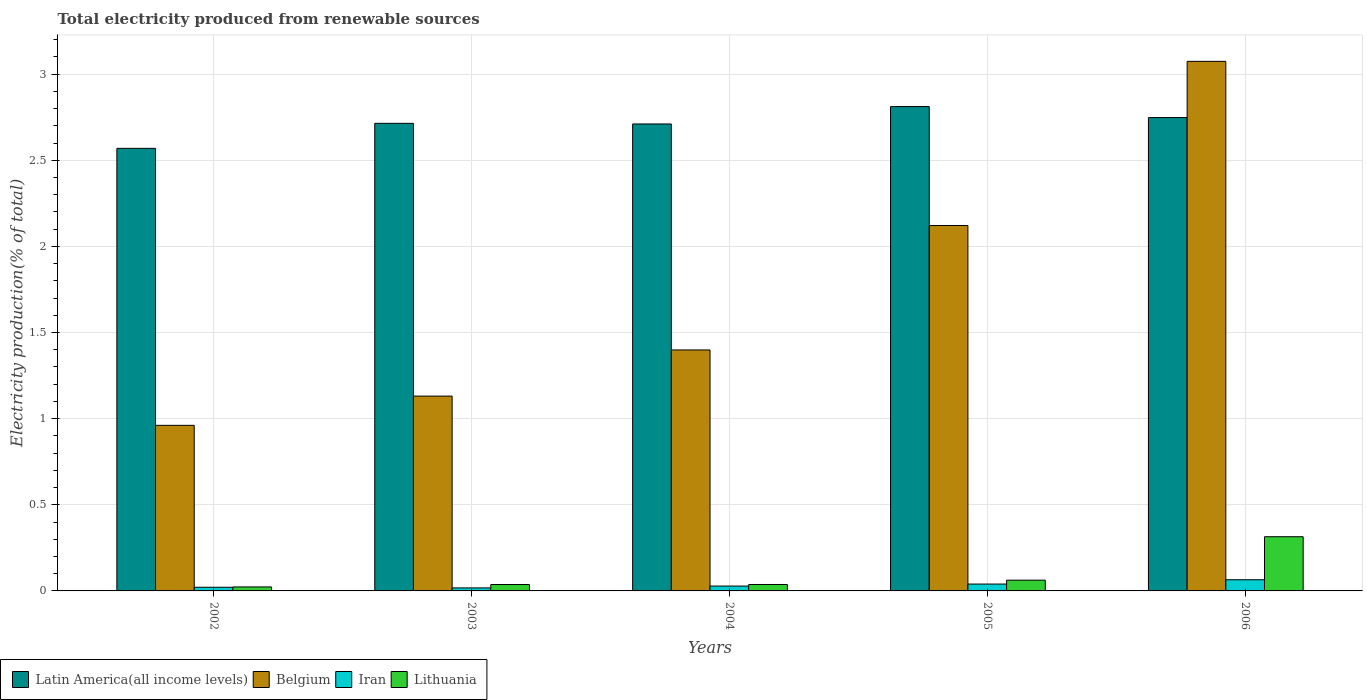How many different coloured bars are there?
Your answer should be compact. 4. How many groups of bars are there?
Give a very brief answer. 5. Are the number of bars per tick equal to the number of legend labels?
Keep it short and to the point. Yes. Are the number of bars on each tick of the X-axis equal?
Your answer should be very brief. Yes. How many bars are there on the 1st tick from the right?
Your answer should be very brief. 4. What is the label of the 2nd group of bars from the left?
Keep it short and to the point. 2003. In how many cases, is the number of bars for a given year not equal to the number of legend labels?
Provide a short and direct response. 0. What is the total electricity produced in Belgium in 2006?
Give a very brief answer. 3.07. Across all years, what is the maximum total electricity produced in Lithuania?
Your answer should be compact. 0.31. Across all years, what is the minimum total electricity produced in Belgium?
Keep it short and to the point. 0.96. In which year was the total electricity produced in Belgium maximum?
Give a very brief answer. 2006. What is the total total electricity produced in Latin America(all income levels) in the graph?
Provide a short and direct response. 13.55. What is the difference between the total electricity produced in Iran in 2002 and that in 2005?
Give a very brief answer. -0.02. What is the difference between the total electricity produced in Belgium in 2005 and the total electricity produced in Latin America(all income levels) in 2006?
Your answer should be very brief. -0.63. What is the average total electricity produced in Belgium per year?
Keep it short and to the point. 1.74. In the year 2005, what is the difference between the total electricity produced in Iran and total electricity produced in Latin America(all income levels)?
Keep it short and to the point. -2.77. What is the ratio of the total electricity produced in Iran in 2002 to that in 2006?
Your answer should be very brief. 0.33. Is the total electricity produced in Belgium in 2005 less than that in 2006?
Offer a terse response. Yes. What is the difference between the highest and the second highest total electricity produced in Latin America(all income levels)?
Give a very brief answer. 0.06. What is the difference between the highest and the lowest total electricity produced in Belgium?
Offer a terse response. 2.11. Is it the case that in every year, the sum of the total electricity produced in Latin America(all income levels) and total electricity produced in Lithuania is greater than the sum of total electricity produced in Iran and total electricity produced in Belgium?
Your answer should be very brief. No. What does the 3rd bar from the left in 2003 represents?
Your answer should be compact. Iran. What does the 1st bar from the right in 2002 represents?
Make the answer very short. Lithuania. How many bars are there?
Offer a terse response. 20. How many years are there in the graph?
Offer a terse response. 5. Are the values on the major ticks of Y-axis written in scientific E-notation?
Provide a succinct answer. No. Does the graph contain any zero values?
Your answer should be very brief. No. Does the graph contain grids?
Give a very brief answer. Yes. What is the title of the graph?
Offer a terse response. Total electricity produced from renewable sources. What is the Electricity production(% of total) of Latin America(all income levels) in 2002?
Keep it short and to the point. 2.57. What is the Electricity production(% of total) in Belgium in 2002?
Give a very brief answer. 0.96. What is the Electricity production(% of total) in Iran in 2002?
Your answer should be very brief. 0.02. What is the Electricity production(% of total) of Lithuania in 2002?
Your answer should be very brief. 0.02. What is the Electricity production(% of total) in Latin America(all income levels) in 2003?
Your answer should be compact. 2.71. What is the Electricity production(% of total) of Belgium in 2003?
Ensure brevity in your answer.  1.13. What is the Electricity production(% of total) in Iran in 2003?
Provide a succinct answer. 0.02. What is the Electricity production(% of total) in Lithuania in 2003?
Keep it short and to the point. 0.04. What is the Electricity production(% of total) in Latin America(all income levels) in 2004?
Keep it short and to the point. 2.71. What is the Electricity production(% of total) in Belgium in 2004?
Ensure brevity in your answer.  1.4. What is the Electricity production(% of total) of Iran in 2004?
Offer a terse response. 0.03. What is the Electricity production(% of total) of Lithuania in 2004?
Your answer should be compact. 0.04. What is the Electricity production(% of total) of Latin America(all income levels) in 2005?
Keep it short and to the point. 2.81. What is the Electricity production(% of total) of Belgium in 2005?
Your response must be concise. 2.12. What is the Electricity production(% of total) in Iran in 2005?
Offer a terse response. 0.04. What is the Electricity production(% of total) in Lithuania in 2005?
Keep it short and to the point. 0.06. What is the Electricity production(% of total) of Latin America(all income levels) in 2006?
Offer a terse response. 2.75. What is the Electricity production(% of total) in Belgium in 2006?
Keep it short and to the point. 3.07. What is the Electricity production(% of total) of Iran in 2006?
Keep it short and to the point. 0.06. What is the Electricity production(% of total) in Lithuania in 2006?
Offer a terse response. 0.31. Across all years, what is the maximum Electricity production(% of total) in Latin America(all income levels)?
Make the answer very short. 2.81. Across all years, what is the maximum Electricity production(% of total) in Belgium?
Make the answer very short. 3.07. Across all years, what is the maximum Electricity production(% of total) in Iran?
Your answer should be very brief. 0.06. Across all years, what is the maximum Electricity production(% of total) in Lithuania?
Provide a short and direct response. 0.31. Across all years, what is the minimum Electricity production(% of total) of Latin America(all income levels)?
Provide a short and direct response. 2.57. Across all years, what is the minimum Electricity production(% of total) in Belgium?
Offer a very short reply. 0.96. Across all years, what is the minimum Electricity production(% of total) in Iran?
Your answer should be compact. 0.02. Across all years, what is the minimum Electricity production(% of total) in Lithuania?
Make the answer very short. 0.02. What is the total Electricity production(% of total) of Latin America(all income levels) in the graph?
Ensure brevity in your answer.  13.55. What is the total Electricity production(% of total) in Belgium in the graph?
Offer a very short reply. 8.69. What is the total Electricity production(% of total) of Iran in the graph?
Your answer should be compact. 0.17. What is the total Electricity production(% of total) in Lithuania in the graph?
Keep it short and to the point. 0.47. What is the difference between the Electricity production(% of total) of Latin America(all income levels) in 2002 and that in 2003?
Provide a short and direct response. -0.15. What is the difference between the Electricity production(% of total) of Belgium in 2002 and that in 2003?
Keep it short and to the point. -0.17. What is the difference between the Electricity production(% of total) of Iran in 2002 and that in 2003?
Make the answer very short. 0. What is the difference between the Electricity production(% of total) of Lithuania in 2002 and that in 2003?
Keep it short and to the point. -0.01. What is the difference between the Electricity production(% of total) in Latin America(all income levels) in 2002 and that in 2004?
Ensure brevity in your answer.  -0.14. What is the difference between the Electricity production(% of total) of Belgium in 2002 and that in 2004?
Ensure brevity in your answer.  -0.44. What is the difference between the Electricity production(% of total) of Iran in 2002 and that in 2004?
Offer a terse response. -0.01. What is the difference between the Electricity production(% of total) in Lithuania in 2002 and that in 2004?
Your answer should be very brief. -0.01. What is the difference between the Electricity production(% of total) of Latin America(all income levels) in 2002 and that in 2005?
Your answer should be very brief. -0.24. What is the difference between the Electricity production(% of total) in Belgium in 2002 and that in 2005?
Your answer should be very brief. -1.16. What is the difference between the Electricity production(% of total) in Iran in 2002 and that in 2005?
Offer a very short reply. -0.02. What is the difference between the Electricity production(% of total) of Lithuania in 2002 and that in 2005?
Ensure brevity in your answer.  -0.04. What is the difference between the Electricity production(% of total) of Latin America(all income levels) in 2002 and that in 2006?
Ensure brevity in your answer.  -0.18. What is the difference between the Electricity production(% of total) in Belgium in 2002 and that in 2006?
Make the answer very short. -2.11. What is the difference between the Electricity production(% of total) in Iran in 2002 and that in 2006?
Give a very brief answer. -0.04. What is the difference between the Electricity production(% of total) in Lithuania in 2002 and that in 2006?
Provide a succinct answer. -0.29. What is the difference between the Electricity production(% of total) of Latin America(all income levels) in 2003 and that in 2004?
Give a very brief answer. 0. What is the difference between the Electricity production(% of total) of Belgium in 2003 and that in 2004?
Provide a succinct answer. -0.27. What is the difference between the Electricity production(% of total) of Iran in 2003 and that in 2004?
Offer a terse response. -0.01. What is the difference between the Electricity production(% of total) of Lithuania in 2003 and that in 2004?
Make the answer very short. -0. What is the difference between the Electricity production(% of total) of Latin America(all income levels) in 2003 and that in 2005?
Give a very brief answer. -0.1. What is the difference between the Electricity production(% of total) in Belgium in 2003 and that in 2005?
Your answer should be very brief. -0.99. What is the difference between the Electricity production(% of total) of Iran in 2003 and that in 2005?
Your response must be concise. -0.02. What is the difference between the Electricity production(% of total) of Lithuania in 2003 and that in 2005?
Your response must be concise. -0.03. What is the difference between the Electricity production(% of total) in Latin America(all income levels) in 2003 and that in 2006?
Ensure brevity in your answer.  -0.03. What is the difference between the Electricity production(% of total) in Belgium in 2003 and that in 2006?
Your answer should be compact. -1.94. What is the difference between the Electricity production(% of total) of Iran in 2003 and that in 2006?
Your answer should be compact. -0.05. What is the difference between the Electricity production(% of total) of Lithuania in 2003 and that in 2006?
Give a very brief answer. -0.28. What is the difference between the Electricity production(% of total) in Latin America(all income levels) in 2004 and that in 2005?
Your answer should be compact. -0.1. What is the difference between the Electricity production(% of total) of Belgium in 2004 and that in 2005?
Ensure brevity in your answer.  -0.72. What is the difference between the Electricity production(% of total) of Iran in 2004 and that in 2005?
Offer a terse response. -0.01. What is the difference between the Electricity production(% of total) in Lithuania in 2004 and that in 2005?
Make the answer very short. -0.03. What is the difference between the Electricity production(% of total) of Latin America(all income levels) in 2004 and that in 2006?
Give a very brief answer. -0.04. What is the difference between the Electricity production(% of total) of Belgium in 2004 and that in 2006?
Offer a terse response. -1.68. What is the difference between the Electricity production(% of total) in Iran in 2004 and that in 2006?
Offer a very short reply. -0.04. What is the difference between the Electricity production(% of total) of Lithuania in 2004 and that in 2006?
Your response must be concise. -0.28. What is the difference between the Electricity production(% of total) of Latin America(all income levels) in 2005 and that in 2006?
Your answer should be very brief. 0.06. What is the difference between the Electricity production(% of total) in Belgium in 2005 and that in 2006?
Your answer should be very brief. -0.95. What is the difference between the Electricity production(% of total) of Iran in 2005 and that in 2006?
Ensure brevity in your answer.  -0.03. What is the difference between the Electricity production(% of total) in Lithuania in 2005 and that in 2006?
Make the answer very short. -0.25. What is the difference between the Electricity production(% of total) of Latin America(all income levels) in 2002 and the Electricity production(% of total) of Belgium in 2003?
Your answer should be very brief. 1.44. What is the difference between the Electricity production(% of total) in Latin America(all income levels) in 2002 and the Electricity production(% of total) in Iran in 2003?
Give a very brief answer. 2.55. What is the difference between the Electricity production(% of total) of Latin America(all income levels) in 2002 and the Electricity production(% of total) of Lithuania in 2003?
Offer a very short reply. 2.53. What is the difference between the Electricity production(% of total) of Belgium in 2002 and the Electricity production(% of total) of Iran in 2003?
Keep it short and to the point. 0.94. What is the difference between the Electricity production(% of total) in Belgium in 2002 and the Electricity production(% of total) in Lithuania in 2003?
Ensure brevity in your answer.  0.92. What is the difference between the Electricity production(% of total) in Iran in 2002 and the Electricity production(% of total) in Lithuania in 2003?
Your response must be concise. -0.02. What is the difference between the Electricity production(% of total) in Latin America(all income levels) in 2002 and the Electricity production(% of total) in Belgium in 2004?
Ensure brevity in your answer.  1.17. What is the difference between the Electricity production(% of total) of Latin America(all income levels) in 2002 and the Electricity production(% of total) of Iran in 2004?
Keep it short and to the point. 2.54. What is the difference between the Electricity production(% of total) of Latin America(all income levels) in 2002 and the Electricity production(% of total) of Lithuania in 2004?
Give a very brief answer. 2.53. What is the difference between the Electricity production(% of total) of Belgium in 2002 and the Electricity production(% of total) of Iran in 2004?
Your answer should be compact. 0.93. What is the difference between the Electricity production(% of total) of Belgium in 2002 and the Electricity production(% of total) of Lithuania in 2004?
Your answer should be compact. 0.92. What is the difference between the Electricity production(% of total) of Iran in 2002 and the Electricity production(% of total) of Lithuania in 2004?
Your response must be concise. -0.02. What is the difference between the Electricity production(% of total) of Latin America(all income levels) in 2002 and the Electricity production(% of total) of Belgium in 2005?
Give a very brief answer. 0.45. What is the difference between the Electricity production(% of total) of Latin America(all income levels) in 2002 and the Electricity production(% of total) of Iran in 2005?
Your response must be concise. 2.53. What is the difference between the Electricity production(% of total) of Latin America(all income levels) in 2002 and the Electricity production(% of total) of Lithuania in 2005?
Your answer should be very brief. 2.51. What is the difference between the Electricity production(% of total) of Belgium in 2002 and the Electricity production(% of total) of Iran in 2005?
Ensure brevity in your answer.  0.92. What is the difference between the Electricity production(% of total) of Belgium in 2002 and the Electricity production(% of total) of Lithuania in 2005?
Provide a short and direct response. 0.9. What is the difference between the Electricity production(% of total) in Iran in 2002 and the Electricity production(% of total) in Lithuania in 2005?
Offer a terse response. -0.04. What is the difference between the Electricity production(% of total) of Latin America(all income levels) in 2002 and the Electricity production(% of total) of Belgium in 2006?
Offer a terse response. -0.51. What is the difference between the Electricity production(% of total) in Latin America(all income levels) in 2002 and the Electricity production(% of total) in Iran in 2006?
Offer a terse response. 2.5. What is the difference between the Electricity production(% of total) in Latin America(all income levels) in 2002 and the Electricity production(% of total) in Lithuania in 2006?
Offer a terse response. 2.25. What is the difference between the Electricity production(% of total) of Belgium in 2002 and the Electricity production(% of total) of Iran in 2006?
Your answer should be very brief. 0.9. What is the difference between the Electricity production(% of total) of Belgium in 2002 and the Electricity production(% of total) of Lithuania in 2006?
Offer a very short reply. 0.65. What is the difference between the Electricity production(% of total) of Iran in 2002 and the Electricity production(% of total) of Lithuania in 2006?
Give a very brief answer. -0.29. What is the difference between the Electricity production(% of total) of Latin America(all income levels) in 2003 and the Electricity production(% of total) of Belgium in 2004?
Keep it short and to the point. 1.32. What is the difference between the Electricity production(% of total) in Latin America(all income levels) in 2003 and the Electricity production(% of total) in Iran in 2004?
Offer a very short reply. 2.69. What is the difference between the Electricity production(% of total) in Latin America(all income levels) in 2003 and the Electricity production(% of total) in Lithuania in 2004?
Ensure brevity in your answer.  2.68. What is the difference between the Electricity production(% of total) of Belgium in 2003 and the Electricity production(% of total) of Iran in 2004?
Offer a terse response. 1.1. What is the difference between the Electricity production(% of total) in Belgium in 2003 and the Electricity production(% of total) in Lithuania in 2004?
Make the answer very short. 1.09. What is the difference between the Electricity production(% of total) in Iran in 2003 and the Electricity production(% of total) in Lithuania in 2004?
Keep it short and to the point. -0.02. What is the difference between the Electricity production(% of total) in Latin America(all income levels) in 2003 and the Electricity production(% of total) in Belgium in 2005?
Your answer should be very brief. 0.59. What is the difference between the Electricity production(% of total) of Latin America(all income levels) in 2003 and the Electricity production(% of total) of Iran in 2005?
Provide a short and direct response. 2.67. What is the difference between the Electricity production(% of total) in Latin America(all income levels) in 2003 and the Electricity production(% of total) in Lithuania in 2005?
Your response must be concise. 2.65. What is the difference between the Electricity production(% of total) of Belgium in 2003 and the Electricity production(% of total) of Iran in 2005?
Keep it short and to the point. 1.09. What is the difference between the Electricity production(% of total) of Belgium in 2003 and the Electricity production(% of total) of Lithuania in 2005?
Make the answer very short. 1.07. What is the difference between the Electricity production(% of total) of Iran in 2003 and the Electricity production(% of total) of Lithuania in 2005?
Provide a succinct answer. -0.04. What is the difference between the Electricity production(% of total) in Latin America(all income levels) in 2003 and the Electricity production(% of total) in Belgium in 2006?
Offer a very short reply. -0.36. What is the difference between the Electricity production(% of total) of Latin America(all income levels) in 2003 and the Electricity production(% of total) of Iran in 2006?
Keep it short and to the point. 2.65. What is the difference between the Electricity production(% of total) of Latin America(all income levels) in 2003 and the Electricity production(% of total) of Lithuania in 2006?
Provide a succinct answer. 2.4. What is the difference between the Electricity production(% of total) in Belgium in 2003 and the Electricity production(% of total) in Iran in 2006?
Your response must be concise. 1.07. What is the difference between the Electricity production(% of total) in Belgium in 2003 and the Electricity production(% of total) in Lithuania in 2006?
Make the answer very short. 0.82. What is the difference between the Electricity production(% of total) in Iran in 2003 and the Electricity production(% of total) in Lithuania in 2006?
Keep it short and to the point. -0.3. What is the difference between the Electricity production(% of total) of Latin America(all income levels) in 2004 and the Electricity production(% of total) of Belgium in 2005?
Your answer should be very brief. 0.59. What is the difference between the Electricity production(% of total) in Latin America(all income levels) in 2004 and the Electricity production(% of total) in Iran in 2005?
Your answer should be very brief. 2.67. What is the difference between the Electricity production(% of total) in Latin America(all income levels) in 2004 and the Electricity production(% of total) in Lithuania in 2005?
Give a very brief answer. 2.65. What is the difference between the Electricity production(% of total) in Belgium in 2004 and the Electricity production(% of total) in Iran in 2005?
Give a very brief answer. 1.36. What is the difference between the Electricity production(% of total) of Belgium in 2004 and the Electricity production(% of total) of Lithuania in 2005?
Your answer should be compact. 1.34. What is the difference between the Electricity production(% of total) of Iran in 2004 and the Electricity production(% of total) of Lithuania in 2005?
Your answer should be very brief. -0.03. What is the difference between the Electricity production(% of total) in Latin America(all income levels) in 2004 and the Electricity production(% of total) in Belgium in 2006?
Make the answer very short. -0.36. What is the difference between the Electricity production(% of total) of Latin America(all income levels) in 2004 and the Electricity production(% of total) of Iran in 2006?
Make the answer very short. 2.65. What is the difference between the Electricity production(% of total) of Latin America(all income levels) in 2004 and the Electricity production(% of total) of Lithuania in 2006?
Keep it short and to the point. 2.4. What is the difference between the Electricity production(% of total) of Belgium in 2004 and the Electricity production(% of total) of Iran in 2006?
Give a very brief answer. 1.33. What is the difference between the Electricity production(% of total) in Belgium in 2004 and the Electricity production(% of total) in Lithuania in 2006?
Give a very brief answer. 1.08. What is the difference between the Electricity production(% of total) in Iran in 2004 and the Electricity production(% of total) in Lithuania in 2006?
Make the answer very short. -0.29. What is the difference between the Electricity production(% of total) in Latin America(all income levels) in 2005 and the Electricity production(% of total) in Belgium in 2006?
Offer a very short reply. -0.26. What is the difference between the Electricity production(% of total) in Latin America(all income levels) in 2005 and the Electricity production(% of total) in Iran in 2006?
Provide a short and direct response. 2.75. What is the difference between the Electricity production(% of total) in Latin America(all income levels) in 2005 and the Electricity production(% of total) in Lithuania in 2006?
Your answer should be very brief. 2.5. What is the difference between the Electricity production(% of total) in Belgium in 2005 and the Electricity production(% of total) in Iran in 2006?
Offer a very short reply. 2.06. What is the difference between the Electricity production(% of total) in Belgium in 2005 and the Electricity production(% of total) in Lithuania in 2006?
Provide a short and direct response. 1.81. What is the difference between the Electricity production(% of total) in Iran in 2005 and the Electricity production(% of total) in Lithuania in 2006?
Offer a terse response. -0.27. What is the average Electricity production(% of total) of Latin America(all income levels) per year?
Give a very brief answer. 2.71. What is the average Electricity production(% of total) in Belgium per year?
Keep it short and to the point. 1.74. What is the average Electricity production(% of total) of Iran per year?
Provide a short and direct response. 0.03. What is the average Electricity production(% of total) of Lithuania per year?
Provide a short and direct response. 0.09. In the year 2002, what is the difference between the Electricity production(% of total) in Latin America(all income levels) and Electricity production(% of total) in Belgium?
Give a very brief answer. 1.61. In the year 2002, what is the difference between the Electricity production(% of total) in Latin America(all income levels) and Electricity production(% of total) in Iran?
Ensure brevity in your answer.  2.55. In the year 2002, what is the difference between the Electricity production(% of total) in Latin America(all income levels) and Electricity production(% of total) in Lithuania?
Provide a short and direct response. 2.55. In the year 2002, what is the difference between the Electricity production(% of total) of Belgium and Electricity production(% of total) of Iran?
Provide a short and direct response. 0.94. In the year 2002, what is the difference between the Electricity production(% of total) of Belgium and Electricity production(% of total) of Lithuania?
Offer a very short reply. 0.94. In the year 2002, what is the difference between the Electricity production(% of total) of Iran and Electricity production(% of total) of Lithuania?
Offer a very short reply. -0. In the year 2003, what is the difference between the Electricity production(% of total) of Latin America(all income levels) and Electricity production(% of total) of Belgium?
Offer a terse response. 1.58. In the year 2003, what is the difference between the Electricity production(% of total) in Latin America(all income levels) and Electricity production(% of total) in Iran?
Provide a short and direct response. 2.7. In the year 2003, what is the difference between the Electricity production(% of total) of Latin America(all income levels) and Electricity production(% of total) of Lithuania?
Offer a terse response. 2.68. In the year 2003, what is the difference between the Electricity production(% of total) of Belgium and Electricity production(% of total) of Iran?
Provide a short and direct response. 1.11. In the year 2003, what is the difference between the Electricity production(% of total) in Belgium and Electricity production(% of total) in Lithuania?
Keep it short and to the point. 1.09. In the year 2003, what is the difference between the Electricity production(% of total) of Iran and Electricity production(% of total) of Lithuania?
Offer a very short reply. -0.02. In the year 2004, what is the difference between the Electricity production(% of total) in Latin America(all income levels) and Electricity production(% of total) in Belgium?
Your response must be concise. 1.31. In the year 2004, what is the difference between the Electricity production(% of total) of Latin America(all income levels) and Electricity production(% of total) of Iran?
Your answer should be compact. 2.68. In the year 2004, what is the difference between the Electricity production(% of total) in Latin America(all income levels) and Electricity production(% of total) in Lithuania?
Offer a terse response. 2.67. In the year 2004, what is the difference between the Electricity production(% of total) in Belgium and Electricity production(% of total) in Iran?
Your answer should be compact. 1.37. In the year 2004, what is the difference between the Electricity production(% of total) of Belgium and Electricity production(% of total) of Lithuania?
Make the answer very short. 1.36. In the year 2004, what is the difference between the Electricity production(% of total) in Iran and Electricity production(% of total) in Lithuania?
Keep it short and to the point. -0.01. In the year 2005, what is the difference between the Electricity production(% of total) in Latin America(all income levels) and Electricity production(% of total) in Belgium?
Provide a short and direct response. 0.69. In the year 2005, what is the difference between the Electricity production(% of total) of Latin America(all income levels) and Electricity production(% of total) of Iran?
Keep it short and to the point. 2.77. In the year 2005, what is the difference between the Electricity production(% of total) of Latin America(all income levels) and Electricity production(% of total) of Lithuania?
Offer a very short reply. 2.75. In the year 2005, what is the difference between the Electricity production(% of total) of Belgium and Electricity production(% of total) of Iran?
Ensure brevity in your answer.  2.08. In the year 2005, what is the difference between the Electricity production(% of total) of Belgium and Electricity production(% of total) of Lithuania?
Your response must be concise. 2.06. In the year 2005, what is the difference between the Electricity production(% of total) in Iran and Electricity production(% of total) in Lithuania?
Your response must be concise. -0.02. In the year 2006, what is the difference between the Electricity production(% of total) of Latin America(all income levels) and Electricity production(% of total) of Belgium?
Provide a short and direct response. -0.33. In the year 2006, what is the difference between the Electricity production(% of total) in Latin America(all income levels) and Electricity production(% of total) in Iran?
Provide a short and direct response. 2.68. In the year 2006, what is the difference between the Electricity production(% of total) in Latin America(all income levels) and Electricity production(% of total) in Lithuania?
Ensure brevity in your answer.  2.43. In the year 2006, what is the difference between the Electricity production(% of total) in Belgium and Electricity production(% of total) in Iran?
Your answer should be compact. 3.01. In the year 2006, what is the difference between the Electricity production(% of total) in Belgium and Electricity production(% of total) in Lithuania?
Provide a short and direct response. 2.76. In the year 2006, what is the difference between the Electricity production(% of total) of Iran and Electricity production(% of total) of Lithuania?
Provide a succinct answer. -0.25. What is the ratio of the Electricity production(% of total) in Latin America(all income levels) in 2002 to that in 2003?
Offer a very short reply. 0.95. What is the ratio of the Electricity production(% of total) in Belgium in 2002 to that in 2003?
Provide a succinct answer. 0.85. What is the ratio of the Electricity production(% of total) of Iran in 2002 to that in 2003?
Offer a terse response. 1.21. What is the ratio of the Electricity production(% of total) in Lithuania in 2002 to that in 2003?
Provide a succinct answer. 0.62. What is the ratio of the Electricity production(% of total) of Latin America(all income levels) in 2002 to that in 2004?
Provide a succinct answer. 0.95. What is the ratio of the Electricity production(% of total) in Belgium in 2002 to that in 2004?
Your response must be concise. 0.69. What is the ratio of the Electricity production(% of total) of Iran in 2002 to that in 2004?
Make the answer very short. 0.76. What is the ratio of the Electricity production(% of total) in Lithuania in 2002 to that in 2004?
Your answer should be very brief. 0.62. What is the ratio of the Electricity production(% of total) in Latin America(all income levels) in 2002 to that in 2005?
Give a very brief answer. 0.91. What is the ratio of the Electricity production(% of total) in Belgium in 2002 to that in 2005?
Offer a terse response. 0.45. What is the ratio of the Electricity production(% of total) in Iran in 2002 to that in 2005?
Your answer should be compact. 0.53. What is the ratio of the Electricity production(% of total) in Lithuania in 2002 to that in 2005?
Offer a terse response. 0.37. What is the ratio of the Electricity production(% of total) in Latin America(all income levels) in 2002 to that in 2006?
Your answer should be very brief. 0.94. What is the ratio of the Electricity production(% of total) of Belgium in 2002 to that in 2006?
Your response must be concise. 0.31. What is the ratio of the Electricity production(% of total) in Iran in 2002 to that in 2006?
Keep it short and to the point. 0.33. What is the ratio of the Electricity production(% of total) in Lithuania in 2002 to that in 2006?
Offer a very short reply. 0.07. What is the ratio of the Electricity production(% of total) in Belgium in 2003 to that in 2004?
Provide a succinct answer. 0.81. What is the ratio of the Electricity production(% of total) in Iran in 2003 to that in 2004?
Make the answer very short. 0.62. What is the ratio of the Electricity production(% of total) in Latin America(all income levels) in 2003 to that in 2005?
Give a very brief answer. 0.97. What is the ratio of the Electricity production(% of total) in Belgium in 2003 to that in 2005?
Provide a succinct answer. 0.53. What is the ratio of the Electricity production(% of total) of Iran in 2003 to that in 2005?
Ensure brevity in your answer.  0.44. What is the ratio of the Electricity production(% of total) in Lithuania in 2003 to that in 2005?
Your answer should be very brief. 0.6. What is the ratio of the Electricity production(% of total) of Latin America(all income levels) in 2003 to that in 2006?
Your answer should be compact. 0.99. What is the ratio of the Electricity production(% of total) of Belgium in 2003 to that in 2006?
Offer a very short reply. 0.37. What is the ratio of the Electricity production(% of total) of Iran in 2003 to that in 2006?
Offer a very short reply. 0.27. What is the ratio of the Electricity production(% of total) in Lithuania in 2003 to that in 2006?
Your answer should be very brief. 0.12. What is the ratio of the Electricity production(% of total) of Latin America(all income levels) in 2004 to that in 2005?
Your answer should be very brief. 0.96. What is the ratio of the Electricity production(% of total) in Belgium in 2004 to that in 2005?
Provide a succinct answer. 0.66. What is the ratio of the Electricity production(% of total) in Iran in 2004 to that in 2005?
Make the answer very short. 0.71. What is the ratio of the Electricity production(% of total) of Lithuania in 2004 to that in 2005?
Your response must be concise. 0.6. What is the ratio of the Electricity production(% of total) of Latin America(all income levels) in 2004 to that in 2006?
Provide a short and direct response. 0.99. What is the ratio of the Electricity production(% of total) in Belgium in 2004 to that in 2006?
Make the answer very short. 0.46. What is the ratio of the Electricity production(% of total) in Iran in 2004 to that in 2006?
Ensure brevity in your answer.  0.43. What is the ratio of the Electricity production(% of total) of Lithuania in 2004 to that in 2006?
Your answer should be very brief. 0.12. What is the ratio of the Electricity production(% of total) of Latin America(all income levels) in 2005 to that in 2006?
Your answer should be very brief. 1.02. What is the ratio of the Electricity production(% of total) of Belgium in 2005 to that in 2006?
Give a very brief answer. 0.69. What is the ratio of the Electricity production(% of total) in Iran in 2005 to that in 2006?
Ensure brevity in your answer.  0.61. What is the ratio of the Electricity production(% of total) in Lithuania in 2005 to that in 2006?
Make the answer very short. 0.2. What is the difference between the highest and the second highest Electricity production(% of total) of Latin America(all income levels)?
Ensure brevity in your answer.  0.06. What is the difference between the highest and the second highest Electricity production(% of total) of Belgium?
Your answer should be very brief. 0.95. What is the difference between the highest and the second highest Electricity production(% of total) in Iran?
Offer a very short reply. 0.03. What is the difference between the highest and the second highest Electricity production(% of total) of Lithuania?
Ensure brevity in your answer.  0.25. What is the difference between the highest and the lowest Electricity production(% of total) of Latin America(all income levels)?
Give a very brief answer. 0.24. What is the difference between the highest and the lowest Electricity production(% of total) in Belgium?
Provide a short and direct response. 2.11. What is the difference between the highest and the lowest Electricity production(% of total) in Iran?
Offer a terse response. 0.05. What is the difference between the highest and the lowest Electricity production(% of total) in Lithuania?
Make the answer very short. 0.29. 